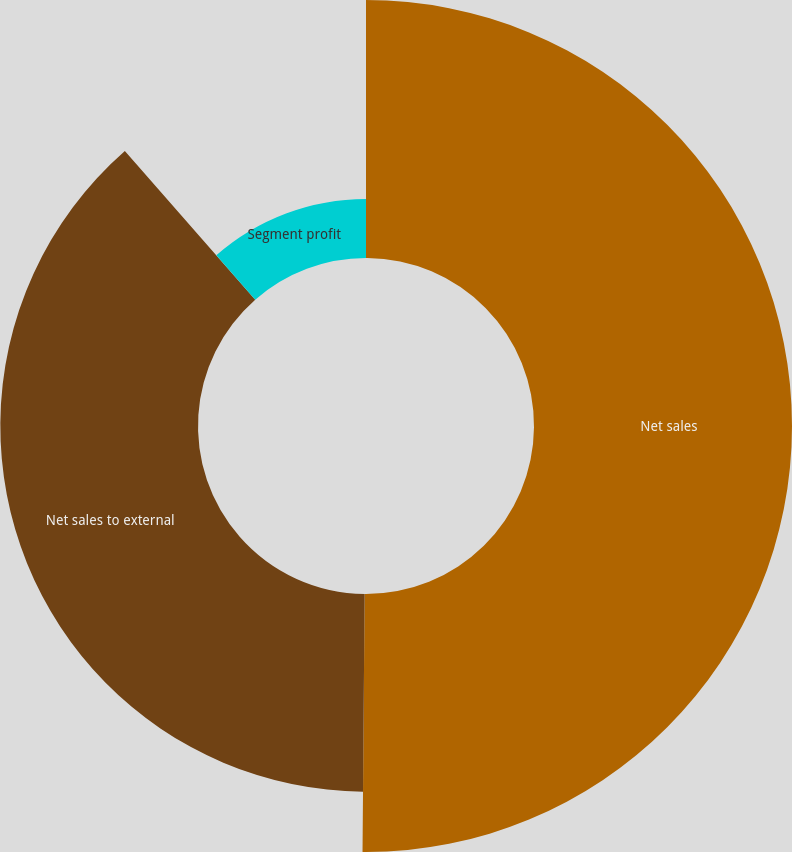<chart> <loc_0><loc_0><loc_500><loc_500><pie_chart><fcel>Net sales<fcel>Net sales to external<fcel>Segment profit<nl><fcel>50.13%<fcel>38.41%<fcel>11.46%<nl></chart> 